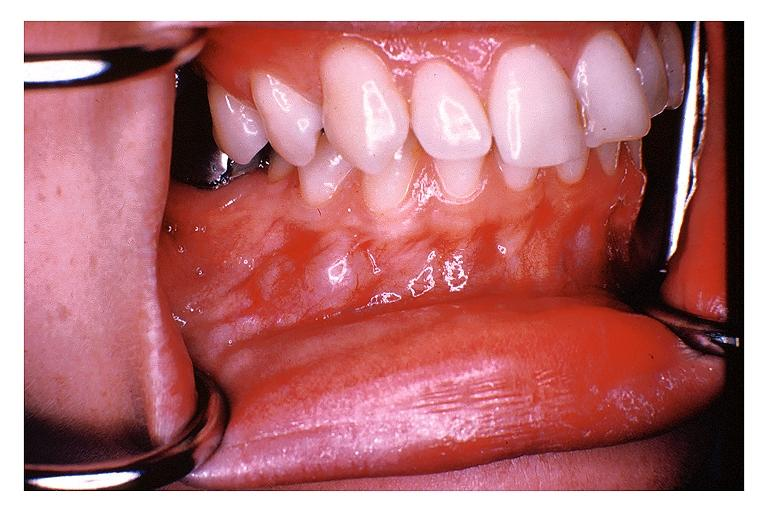what does this image show?
Answer the question using a single word or phrase. Traumatic neuroma 